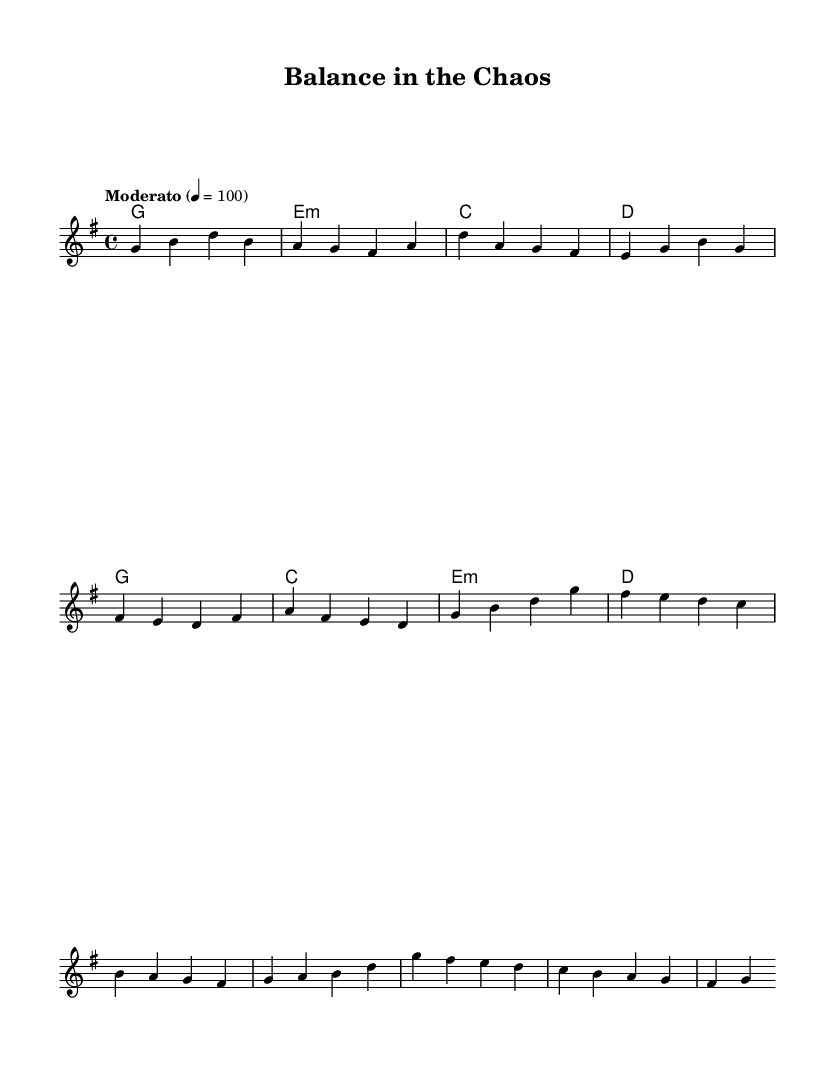What is the key signature of this music? The key signature is G major, which has one sharp (F#). This is determined by the symbol in the beginning of the score, indicating the tonal center.
Answer: G major What is the time signature of this music? The time signature is 4/4, which is represented at the beginning of the score. It indicates that there are four beats in each measure and a quarter note receives one beat.
Answer: 4/4 What tempo marking is used in this music? The tempo marking is "Moderato," which is indicated in the tempo text above the staff. This suggests a moderate pace of 100 beats per minute.
Answer: Moderato How many measures are in the verse section of the music? The verse section consists of six measures, as counted from the beginning of the melody line through to the end of the verse. Each measure is separated by vertical lines.
Answer: six How does the chord progression change from verse to chorus? The chord progression moves from G, E minor, C, D in the verse to G, C, E minor, D in the chorus. By comparing the two sections, we can identify the difference in the second and third chords.
Answer: G, E minor, C, D; G, C, E minor, D Which note appears most frequently in the melody? The note G appears frequently throughout the melody, both as a starting note and within phrases, as analyzed by counting its occurrences in the melody line.
Answer: G What type of song structure is suggested by this music? This music suggests a verse-chorus structure typical of pop songs, including distinct sections for verses and choruses as indicated by the labeled sections and different melodies.
Answer: Verse-chorus 